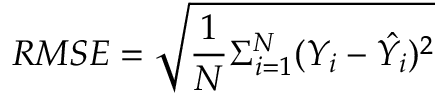<formula> <loc_0><loc_0><loc_500><loc_500>R M S E = \sqrt { \frac { 1 } { N } \Sigma _ { i = 1 } ^ { N } ( Y _ { i } - \hat { Y _ { i } } ) ^ { 2 } }</formula> 